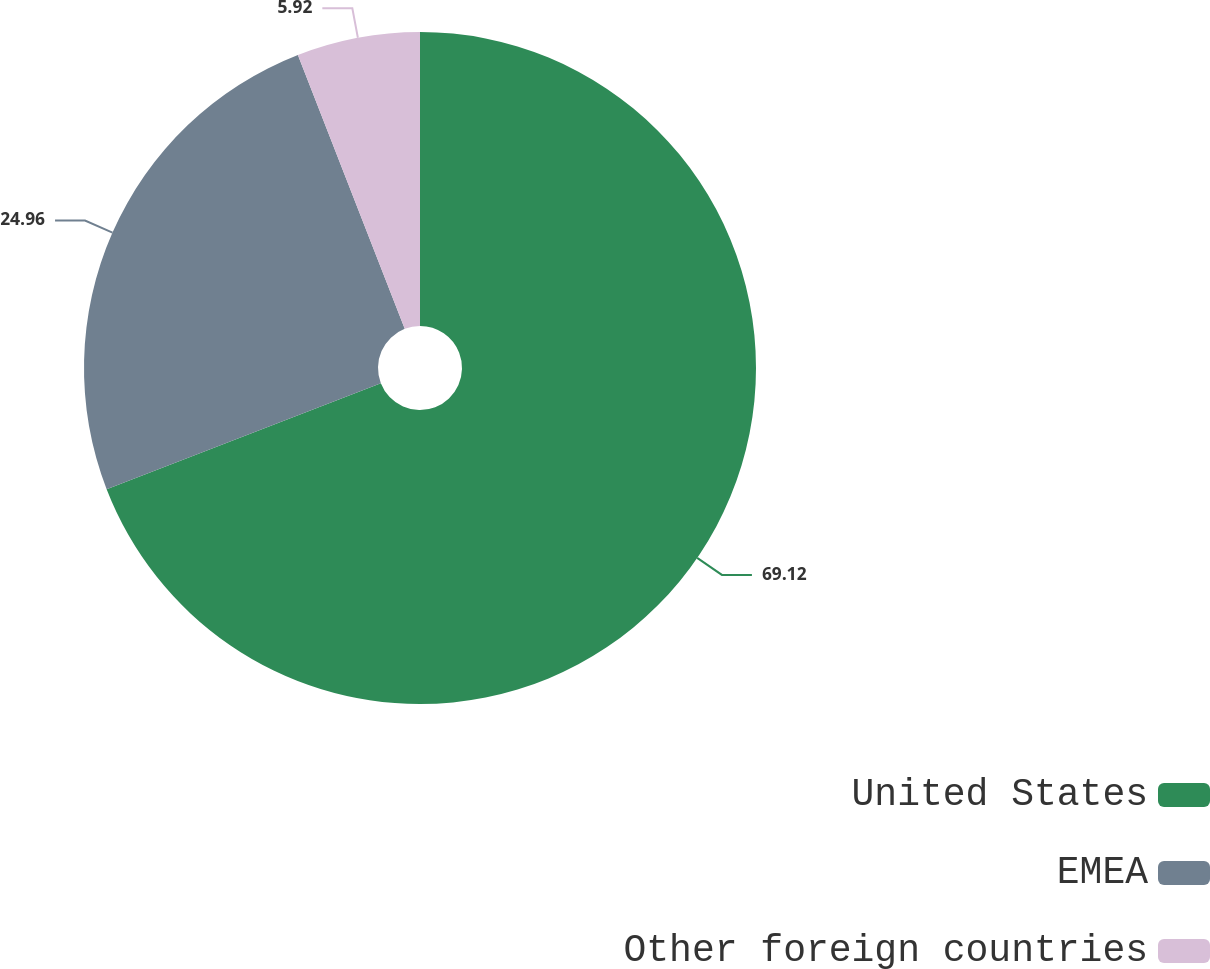<chart> <loc_0><loc_0><loc_500><loc_500><pie_chart><fcel>United States<fcel>EMEA<fcel>Other foreign countries<nl><fcel>69.13%<fcel>24.96%<fcel>5.92%<nl></chart> 